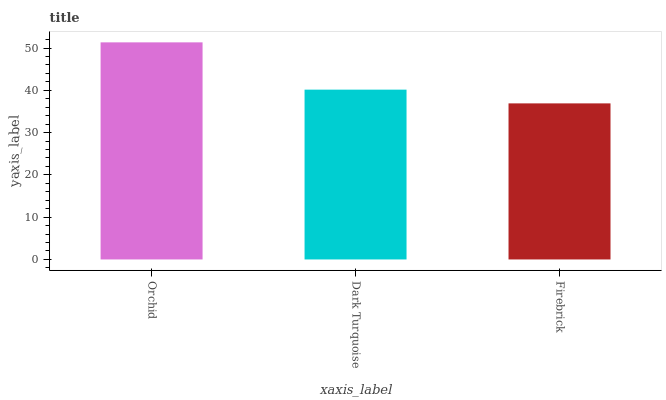Is Firebrick the minimum?
Answer yes or no. Yes. Is Orchid the maximum?
Answer yes or no. Yes. Is Dark Turquoise the minimum?
Answer yes or no. No. Is Dark Turquoise the maximum?
Answer yes or no. No. Is Orchid greater than Dark Turquoise?
Answer yes or no. Yes. Is Dark Turquoise less than Orchid?
Answer yes or no. Yes. Is Dark Turquoise greater than Orchid?
Answer yes or no. No. Is Orchid less than Dark Turquoise?
Answer yes or no. No. Is Dark Turquoise the high median?
Answer yes or no. Yes. Is Dark Turquoise the low median?
Answer yes or no. Yes. Is Firebrick the high median?
Answer yes or no. No. Is Firebrick the low median?
Answer yes or no. No. 